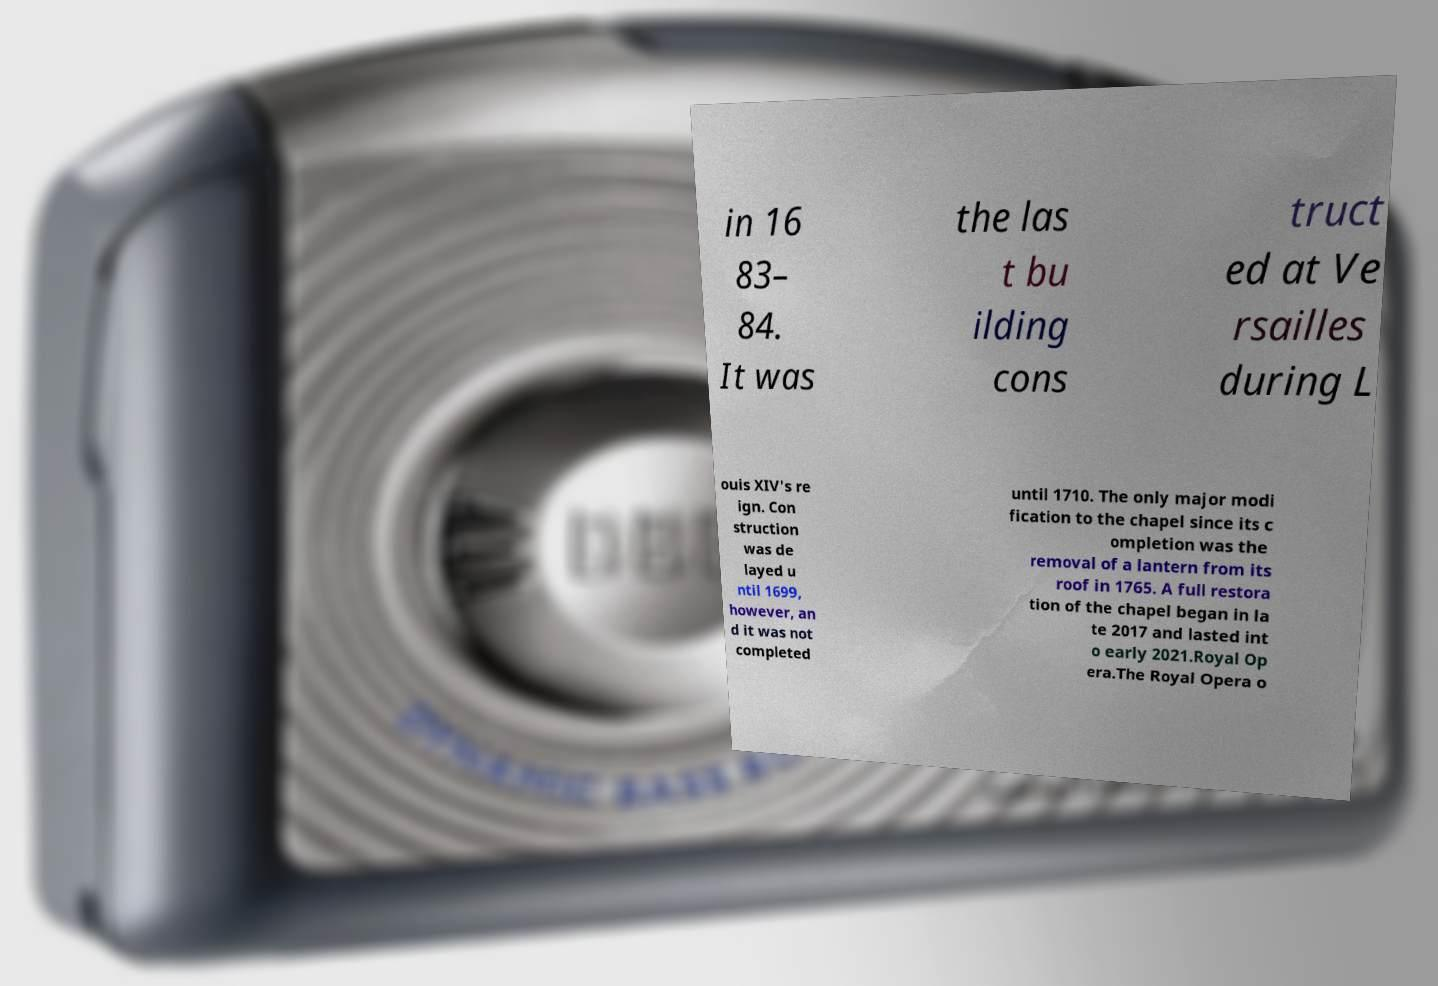Could you extract and type out the text from this image? in 16 83– 84. It was the las t bu ilding cons truct ed at Ve rsailles during L ouis XIV's re ign. Con struction was de layed u ntil 1699, however, an d it was not completed until 1710. The only major modi fication to the chapel since its c ompletion was the removal of a lantern from its roof in 1765. A full restora tion of the chapel began in la te 2017 and lasted int o early 2021.Royal Op era.The Royal Opera o 